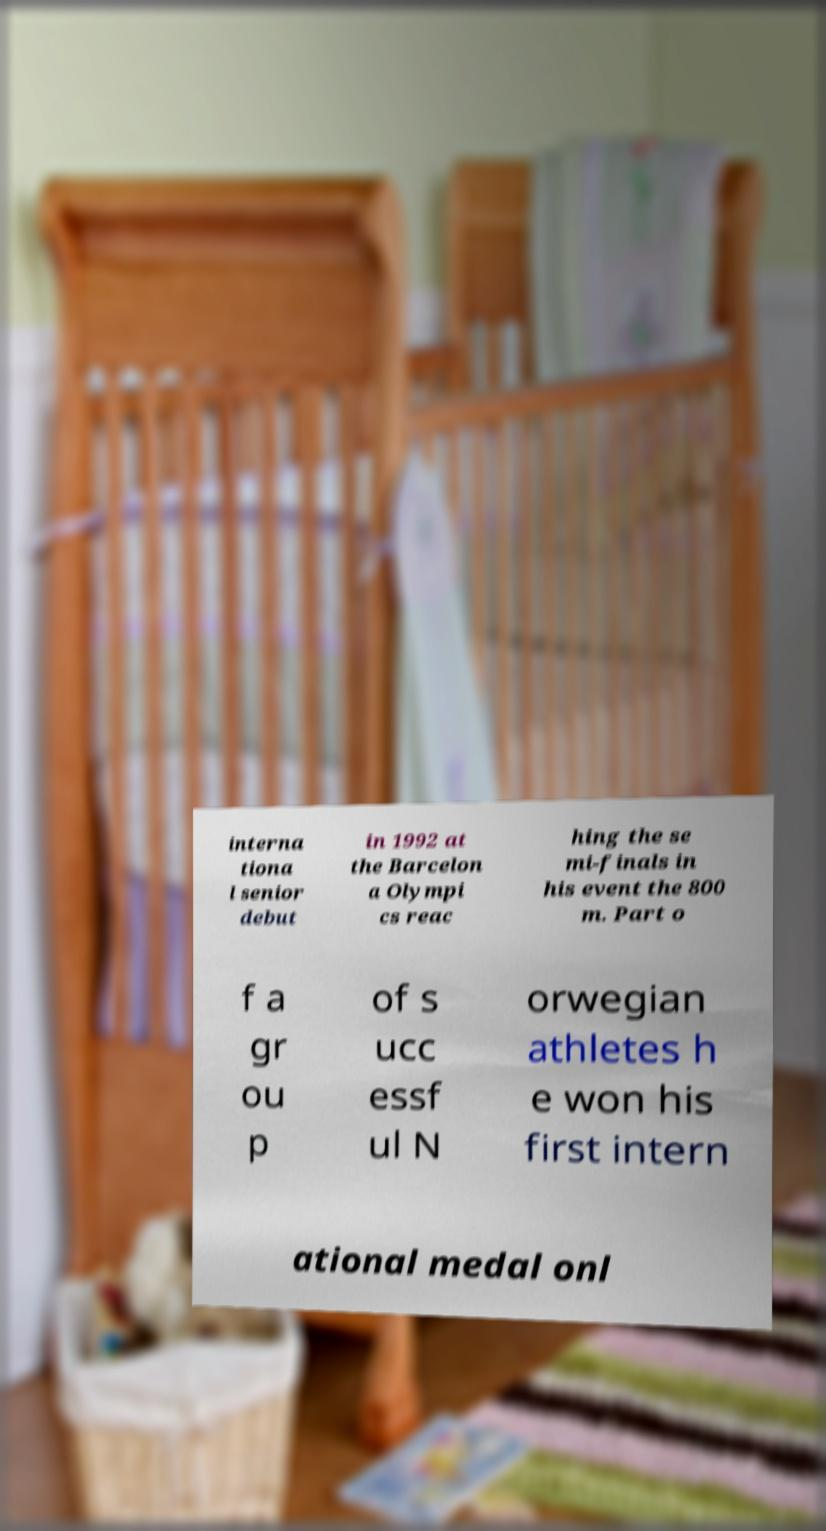There's text embedded in this image that I need extracted. Can you transcribe it verbatim? interna tiona l senior debut in 1992 at the Barcelon a Olympi cs reac hing the se mi-finals in his event the 800 m. Part o f a gr ou p of s ucc essf ul N orwegian athletes h e won his first intern ational medal onl 